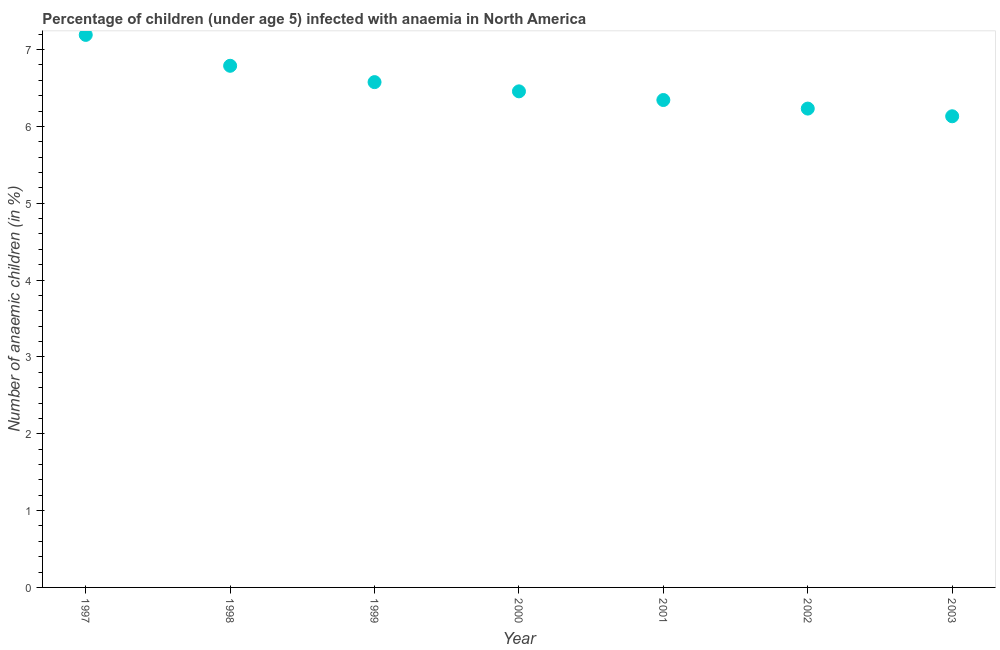What is the number of anaemic children in 2000?
Your response must be concise. 6.46. Across all years, what is the maximum number of anaemic children?
Your response must be concise. 7.19. Across all years, what is the minimum number of anaemic children?
Provide a short and direct response. 6.13. In which year was the number of anaemic children maximum?
Your answer should be very brief. 1997. What is the sum of the number of anaemic children?
Ensure brevity in your answer.  45.72. What is the difference between the number of anaemic children in 2001 and 2003?
Your answer should be compact. 0.21. What is the average number of anaemic children per year?
Your answer should be compact. 6.53. What is the median number of anaemic children?
Make the answer very short. 6.46. What is the ratio of the number of anaemic children in 2002 to that in 2003?
Offer a terse response. 1.02. Is the number of anaemic children in 2001 less than that in 2002?
Keep it short and to the point. No. Is the difference between the number of anaemic children in 1998 and 2001 greater than the difference between any two years?
Offer a terse response. No. What is the difference between the highest and the second highest number of anaemic children?
Provide a succinct answer. 0.4. Is the sum of the number of anaemic children in 1997 and 2002 greater than the maximum number of anaemic children across all years?
Provide a succinct answer. Yes. What is the difference between the highest and the lowest number of anaemic children?
Make the answer very short. 1.06. Does the number of anaemic children monotonically increase over the years?
Provide a succinct answer. No. How many dotlines are there?
Your response must be concise. 1. Does the graph contain any zero values?
Provide a succinct answer. No. What is the title of the graph?
Provide a succinct answer. Percentage of children (under age 5) infected with anaemia in North America. What is the label or title of the X-axis?
Provide a succinct answer. Year. What is the label or title of the Y-axis?
Offer a very short reply. Number of anaemic children (in %). What is the Number of anaemic children (in %) in 1997?
Offer a terse response. 7.19. What is the Number of anaemic children (in %) in 1998?
Your answer should be very brief. 6.79. What is the Number of anaemic children (in %) in 1999?
Make the answer very short. 6.58. What is the Number of anaemic children (in %) in 2000?
Make the answer very short. 6.46. What is the Number of anaemic children (in %) in 2001?
Keep it short and to the point. 6.34. What is the Number of anaemic children (in %) in 2002?
Ensure brevity in your answer.  6.23. What is the Number of anaemic children (in %) in 2003?
Give a very brief answer. 6.13. What is the difference between the Number of anaemic children (in %) in 1997 and 1998?
Your response must be concise. 0.4. What is the difference between the Number of anaemic children (in %) in 1997 and 1999?
Ensure brevity in your answer.  0.61. What is the difference between the Number of anaemic children (in %) in 1997 and 2000?
Give a very brief answer. 0.73. What is the difference between the Number of anaemic children (in %) in 1997 and 2001?
Give a very brief answer. 0.85. What is the difference between the Number of anaemic children (in %) in 1997 and 2002?
Offer a terse response. 0.96. What is the difference between the Number of anaemic children (in %) in 1997 and 2003?
Offer a very short reply. 1.06. What is the difference between the Number of anaemic children (in %) in 1998 and 1999?
Offer a very short reply. 0.21. What is the difference between the Number of anaemic children (in %) in 1998 and 2000?
Provide a succinct answer. 0.33. What is the difference between the Number of anaemic children (in %) in 1998 and 2001?
Your answer should be compact. 0.45. What is the difference between the Number of anaemic children (in %) in 1998 and 2002?
Provide a succinct answer. 0.56. What is the difference between the Number of anaemic children (in %) in 1998 and 2003?
Your answer should be very brief. 0.66. What is the difference between the Number of anaemic children (in %) in 1999 and 2000?
Make the answer very short. 0.12. What is the difference between the Number of anaemic children (in %) in 1999 and 2001?
Give a very brief answer. 0.23. What is the difference between the Number of anaemic children (in %) in 1999 and 2002?
Make the answer very short. 0.34. What is the difference between the Number of anaemic children (in %) in 1999 and 2003?
Make the answer very short. 0.44. What is the difference between the Number of anaemic children (in %) in 2000 and 2001?
Give a very brief answer. 0.11. What is the difference between the Number of anaemic children (in %) in 2000 and 2002?
Your answer should be very brief. 0.22. What is the difference between the Number of anaemic children (in %) in 2000 and 2003?
Provide a succinct answer. 0.32. What is the difference between the Number of anaemic children (in %) in 2001 and 2002?
Make the answer very short. 0.11. What is the difference between the Number of anaemic children (in %) in 2001 and 2003?
Give a very brief answer. 0.21. What is the difference between the Number of anaemic children (in %) in 2002 and 2003?
Provide a succinct answer. 0.1. What is the ratio of the Number of anaemic children (in %) in 1997 to that in 1998?
Ensure brevity in your answer.  1.06. What is the ratio of the Number of anaemic children (in %) in 1997 to that in 1999?
Your response must be concise. 1.09. What is the ratio of the Number of anaemic children (in %) in 1997 to that in 2000?
Give a very brief answer. 1.11. What is the ratio of the Number of anaemic children (in %) in 1997 to that in 2001?
Your response must be concise. 1.13. What is the ratio of the Number of anaemic children (in %) in 1997 to that in 2002?
Your answer should be very brief. 1.15. What is the ratio of the Number of anaemic children (in %) in 1997 to that in 2003?
Give a very brief answer. 1.17. What is the ratio of the Number of anaemic children (in %) in 1998 to that in 1999?
Your response must be concise. 1.03. What is the ratio of the Number of anaemic children (in %) in 1998 to that in 2000?
Offer a terse response. 1.05. What is the ratio of the Number of anaemic children (in %) in 1998 to that in 2001?
Your response must be concise. 1.07. What is the ratio of the Number of anaemic children (in %) in 1998 to that in 2002?
Ensure brevity in your answer.  1.09. What is the ratio of the Number of anaemic children (in %) in 1998 to that in 2003?
Offer a terse response. 1.11. What is the ratio of the Number of anaemic children (in %) in 1999 to that in 2001?
Your answer should be very brief. 1.04. What is the ratio of the Number of anaemic children (in %) in 1999 to that in 2002?
Provide a short and direct response. 1.05. What is the ratio of the Number of anaemic children (in %) in 1999 to that in 2003?
Your answer should be very brief. 1.07. What is the ratio of the Number of anaemic children (in %) in 2000 to that in 2002?
Make the answer very short. 1.04. What is the ratio of the Number of anaemic children (in %) in 2000 to that in 2003?
Keep it short and to the point. 1.05. What is the ratio of the Number of anaemic children (in %) in 2001 to that in 2003?
Keep it short and to the point. 1.03. 